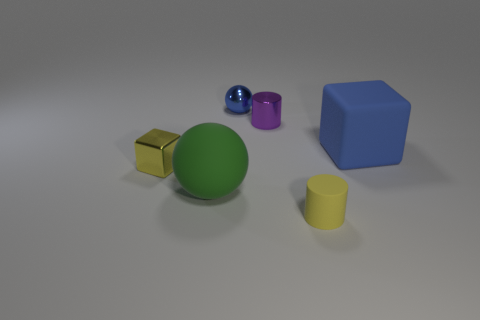Add 1 small cyan rubber spheres. How many objects exist? 7 Subtract all blocks. How many objects are left? 4 Add 3 small matte cylinders. How many small matte cylinders exist? 4 Subtract 1 blue balls. How many objects are left? 5 Subtract all small gray cubes. Subtract all small rubber things. How many objects are left? 5 Add 3 metal objects. How many metal objects are left? 6 